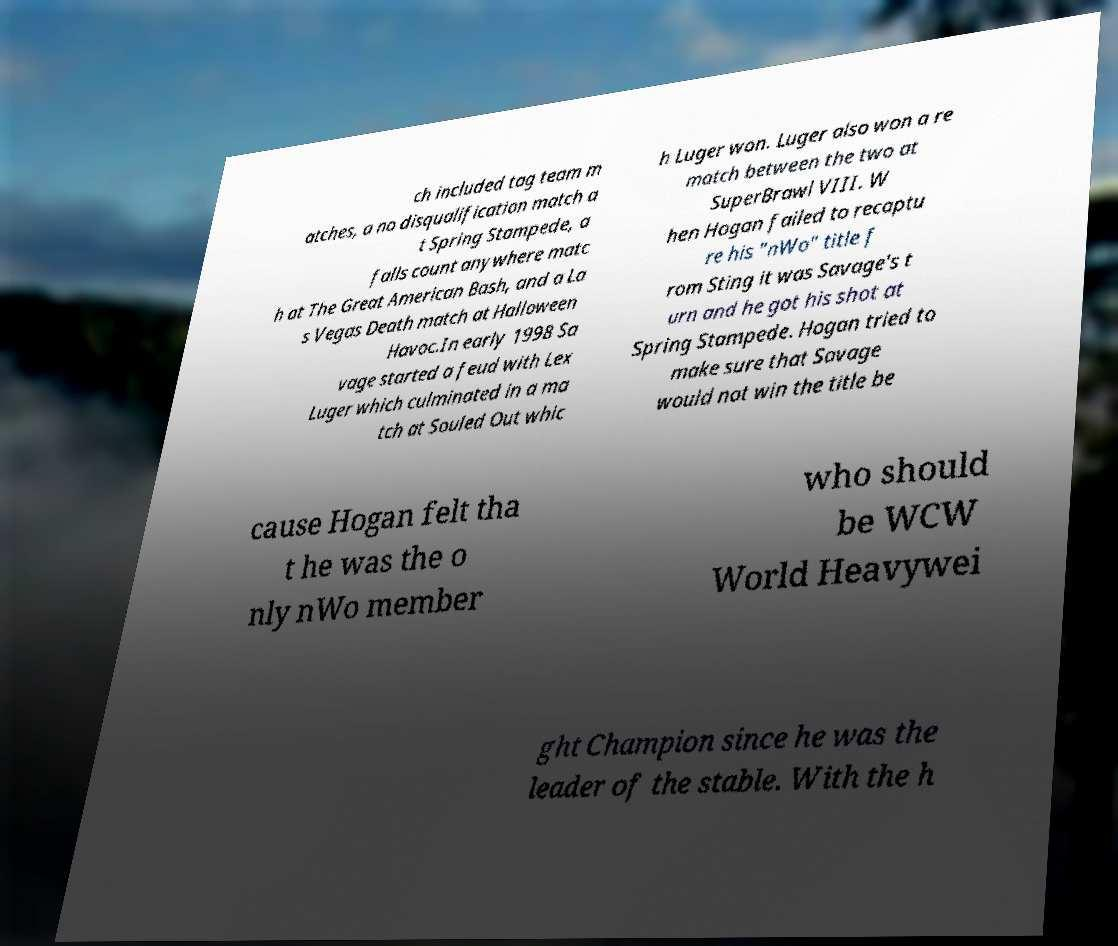There's text embedded in this image that I need extracted. Can you transcribe it verbatim? ch included tag team m atches, a no disqualification match a t Spring Stampede, a falls count anywhere matc h at The Great American Bash, and a La s Vegas Death match at Halloween Havoc.In early 1998 Sa vage started a feud with Lex Luger which culminated in a ma tch at Souled Out whic h Luger won. Luger also won a re match between the two at SuperBrawl VIII. W hen Hogan failed to recaptu re his "nWo" title f rom Sting it was Savage's t urn and he got his shot at Spring Stampede. Hogan tried to make sure that Savage would not win the title be cause Hogan felt tha t he was the o nly nWo member who should be WCW World Heavywei ght Champion since he was the leader of the stable. With the h 